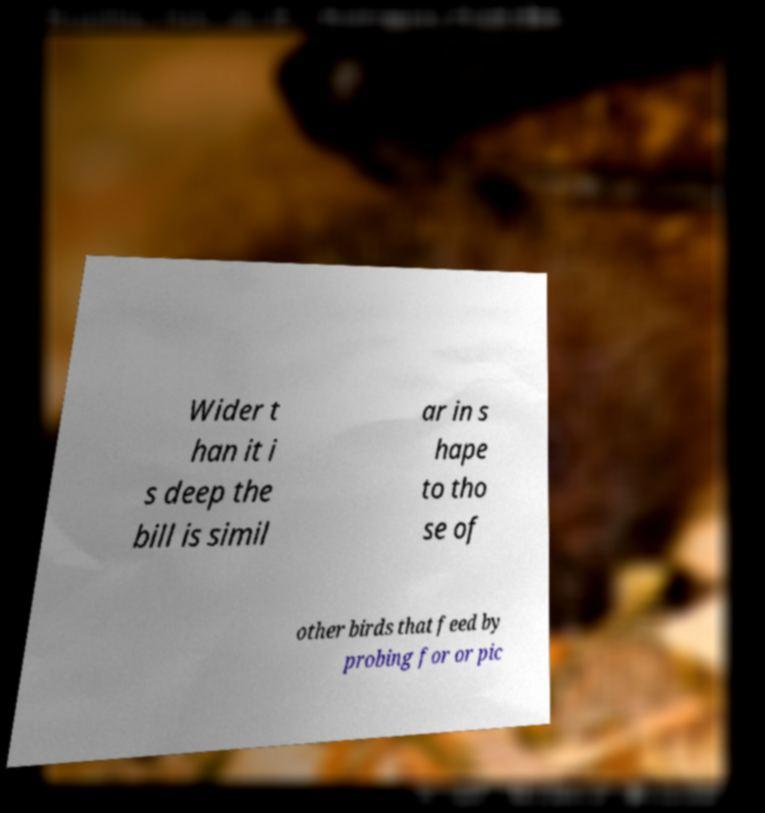There's text embedded in this image that I need extracted. Can you transcribe it verbatim? Wider t han it i s deep the bill is simil ar in s hape to tho se of other birds that feed by probing for or pic 